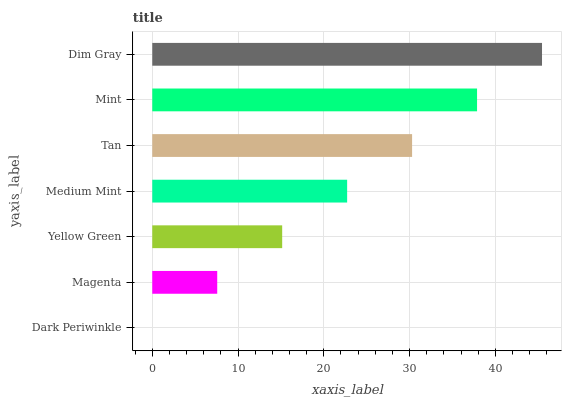Is Dark Periwinkle the minimum?
Answer yes or no. Yes. Is Dim Gray the maximum?
Answer yes or no. Yes. Is Magenta the minimum?
Answer yes or no. No. Is Magenta the maximum?
Answer yes or no. No. Is Magenta greater than Dark Periwinkle?
Answer yes or no. Yes. Is Dark Periwinkle less than Magenta?
Answer yes or no. Yes. Is Dark Periwinkle greater than Magenta?
Answer yes or no. No. Is Magenta less than Dark Periwinkle?
Answer yes or no. No. Is Medium Mint the high median?
Answer yes or no. Yes. Is Medium Mint the low median?
Answer yes or no. Yes. Is Yellow Green the high median?
Answer yes or no. No. Is Dark Periwinkle the low median?
Answer yes or no. No. 